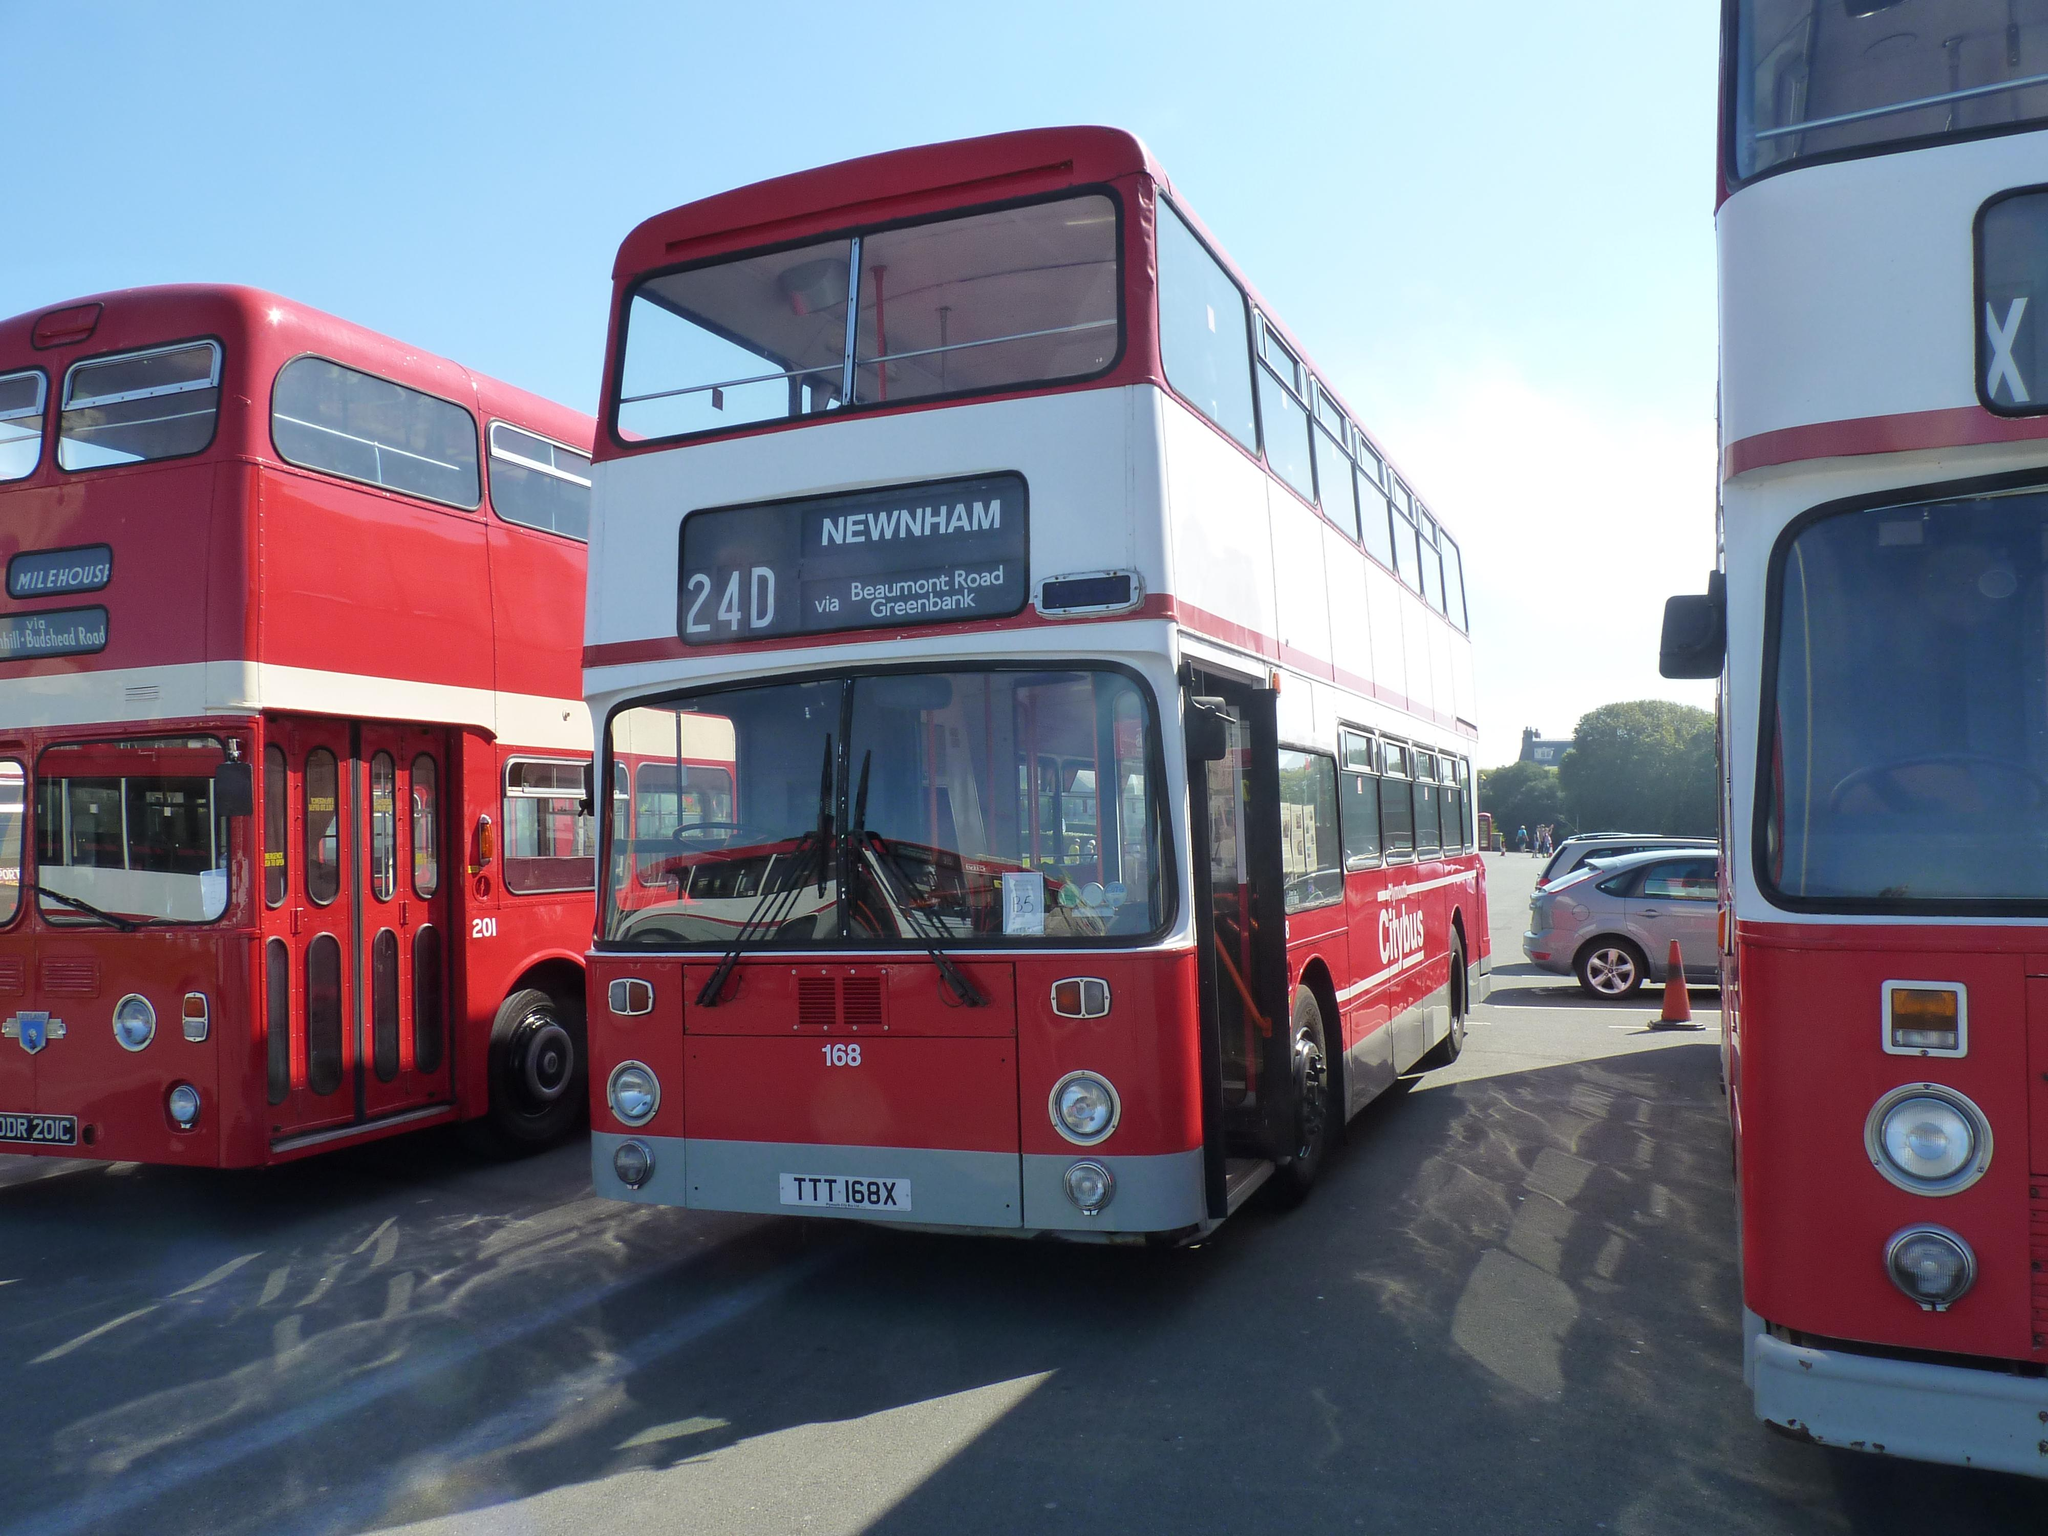What type of vehicles can be seen in the image? There are buses in the image. What object is placed on the road in the image? There is a traffic cone in the image. What other types of vehicles are present on the road? There are cars on the road in the image. What can be seen in the background of the image? There are trees and other objects visible in the background of the image. What part of the natural environment is visible in the image? The sky is visible in the background of the image. What type of cable is being used by the government in the image? There is no mention of a cable or the government in the image; it features buses, a traffic cone, cars, trees, and the sky. 